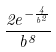Convert formula to latex. <formula><loc_0><loc_0><loc_500><loc_500>\frac { 2 e ^ { - \frac { 4 } { b ^ { 2 } } } } { b ^ { 8 } }</formula> 